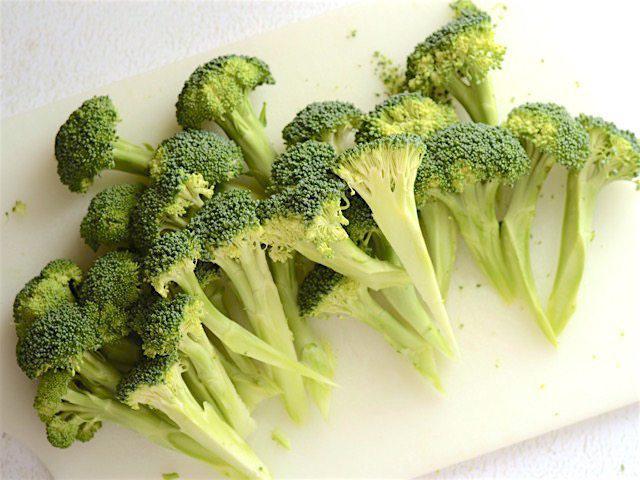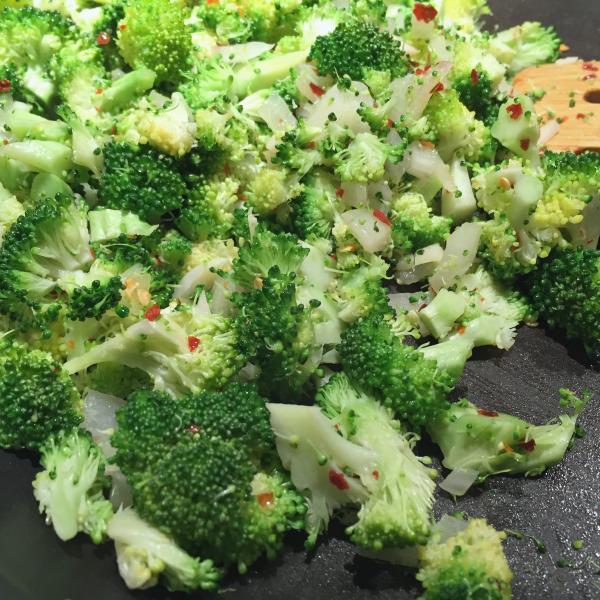The first image is the image on the left, the second image is the image on the right. Given the left and right images, does the statement "One image shows broccoli florets still in the store packaging with a label on the front." hold true? Answer yes or no. No. The first image is the image on the left, the second image is the image on the right. Given the left and right images, does the statement "The broccoli in one of the images is still in the bag." hold true? Answer yes or no. No. 